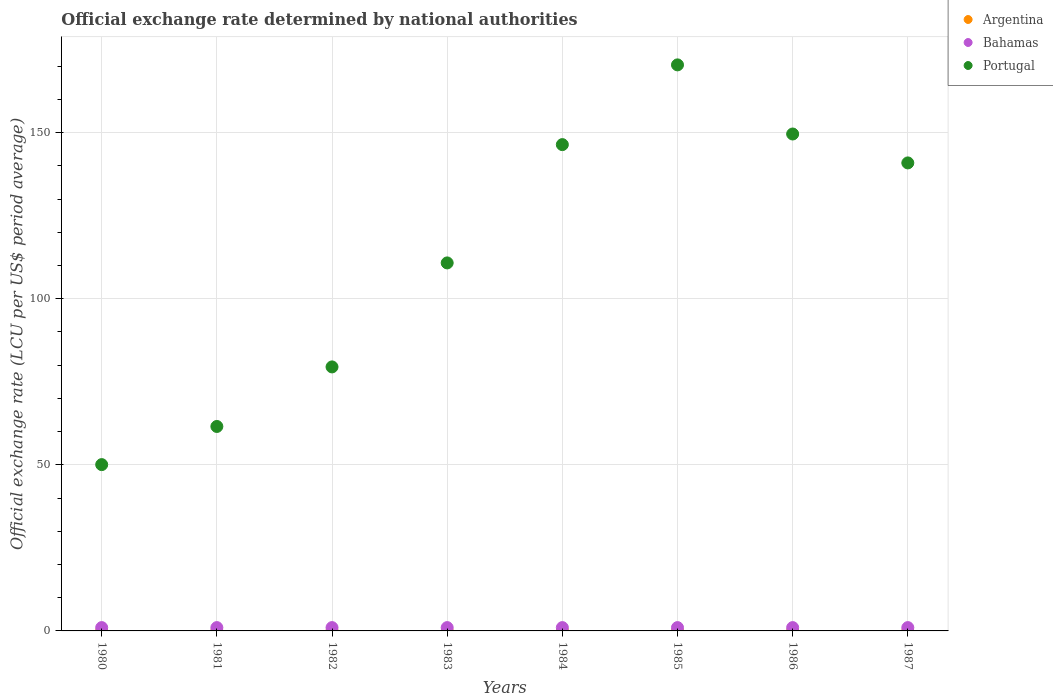How many different coloured dotlines are there?
Give a very brief answer. 3. What is the official exchange rate in Argentina in 1987?
Offer a terse response. 0. Across all years, what is the minimum official exchange rate in Portugal?
Keep it short and to the point. 50.06. In which year was the official exchange rate in Argentina minimum?
Provide a short and direct response. 1980. What is the total official exchange rate in Argentina in the graph?
Ensure brevity in your answer.  0. What is the difference between the official exchange rate in Argentina in 1982 and that in 1987?
Give a very brief answer. -0. What is the difference between the official exchange rate in Bahamas in 1983 and the official exchange rate in Argentina in 1982?
Provide a succinct answer. 1. What is the average official exchange rate in Bahamas per year?
Offer a terse response. 1. In the year 1986, what is the difference between the official exchange rate in Bahamas and official exchange rate in Portugal?
Give a very brief answer. -148.59. What is the ratio of the official exchange rate in Argentina in 1984 to that in 1985?
Provide a succinct answer. 0.11. Is the official exchange rate in Argentina in 1981 less than that in 1986?
Give a very brief answer. Yes. What is the difference between the highest and the second highest official exchange rate in Argentina?
Your answer should be very brief. 0. What is the difference between the highest and the lowest official exchange rate in Bahamas?
Your answer should be very brief. 9.999999717180685e-10. In how many years, is the official exchange rate in Portugal greater than the average official exchange rate in Portugal taken over all years?
Offer a terse response. 4. Is it the case that in every year, the sum of the official exchange rate in Portugal and official exchange rate in Argentina  is greater than the official exchange rate in Bahamas?
Give a very brief answer. Yes. Is the official exchange rate in Portugal strictly less than the official exchange rate in Argentina over the years?
Your answer should be very brief. No. How many years are there in the graph?
Keep it short and to the point. 8. Are the values on the major ticks of Y-axis written in scientific E-notation?
Provide a short and direct response. No. What is the title of the graph?
Give a very brief answer. Official exchange rate determined by national authorities. What is the label or title of the Y-axis?
Give a very brief answer. Official exchange rate (LCU per US$ period average). What is the Official exchange rate (LCU per US$ period average) in Argentina in 1980?
Keep it short and to the point. 1.83715833333225e-8. What is the Official exchange rate (LCU per US$ period average) in Bahamas in 1980?
Your answer should be very brief. 1. What is the Official exchange rate (LCU per US$ period average) of Portugal in 1980?
Offer a very short reply. 50.06. What is the Official exchange rate (LCU per US$ period average) of Argentina in 1981?
Your response must be concise. 4.40269166666725e-8. What is the Official exchange rate (LCU per US$ period average) in Bahamas in 1981?
Offer a very short reply. 1. What is the Official exchange rate (LCU per US$ period average) of Portugal in 1981?
Ensure brevity in your answer.  61.55. What is the Official exchange rate (LCU per US$ period average) of Argentina in 1982?
Make the answer very short. 2.592253333332631e-7. What is the Official exchange rate (LCU per US$ period average) of Bahamas in 1982?
Keep it short and to the point. 1. What is the Official exchange rate (LCU per US$ period average) in Portugal in 1982?
Your response must be concise. 79.47. What is the Official exchange rate (LCU per US$ period average) in Argentina in 1983?
Your answer should be compact. 1.05299574995841e-6. What is the Official exchange rate (LCU per US$ period average) of Bahamas in 1983?
Provide a short and direct response. 1. What is the Official exchange rate (LCU per US$ period average) of Portugal in 1983?
Keep it short and to the point. 110.78. What is the Official exchange rate (LCU per US$ period average) in Argentina in 1984?
Ensure brevity in your answer.  6.7649116666e-6. What is the Official exchange rate (LCU per US$ period average) in Bahamas in 1984?
Your answer should be compact. 1. What is the Official exchange rate (LCU per US$ period average) of Portugal in 1984?
Your response must be concise. 146.39. What is the Official exchange rate (LCU per US$ period average) in Argentina in 1985?
Your answer should be very brief. 6.01809e-5. What is the Official exchange rate (LCU per US$ period average) in Bahamas in 1985?
Your response must be concise. 1. What is the Official exchange rate (LCU per US$ period average) in Portugal in 1985?
Offer a terse response. 170.39. What is the Official exchange rate (LCU per US$ period average) of Argentina in 1986?
Your response must be concise. 9.43031666666667e-5. What is the Official exchange rate (LCU per US$ period average) of Portugal in 1986?
Ensure brevity in your answer.  149.59. What is the Official exchange rate (LCU per US$ period average) in Argentina in 1987?
Give a very brief answer. 0. What is the Official exchange rate (LCU per US$ period average) in Portugal in 1987?
Your answer should be very brief. 140.88. Across all years, what is the maximum Official exchange rate (LCU per US$ period average) of Argentina?
Make the answer very short. 0. Across all years, what is the maximum Official exchange rate (LCU per US$ period average) of Portugal?
Your answer should be compact. 170.39. Across all years, what is the minimum Official exchange rate (LCU per US$ period average) in Argentina?
Make the answer very short. 1.83715833333225e-8. Across all years, what is the minimum Official exchange rate (LCU per US$ period average) of Bahamas?
Keep it short and to the point. 1. Across all years, what is the minimum Official exchange rate (LCU per US$ period average) in Portugal?
Keep it short and to the point. 50.06. What is the total Official exchange rate (LCU per US$ period average) in Argentina in the graph?
Offer a very short reply. 0. What is the total Official exchange rate (LCU per US$ period average) in Portugal in the graph?
Provide a succinct answer. 909.12. What is the difference between the Official exchange rate (LCU per US$ period average) of Bahamas in 1980 and that in 1981?
Provide a short and direct response. 0. What is the difference between the Official exchange rate (LCU per US$ period average) in Portugal in 1980 and that in 1981?
Give a very brief answer. -11.48. What is the difference between the Official exchange rate (LCU per US$ period average) of Argentina in 1980 and that in 1982?
Give a very brief answer. -0. What is the difference between the Official exchange rate (LCU per US$ period average) in Portugal in 1980 and that in 1982?
Your answer should be very brief. -29.41. What is the difference between the Official exchange rate (LCU per US$ period average) of Argentina in 1980 and that in 1983?
Give a very brief answer. -0. What is the difference between the Official exchange rate (LCU per US$ period average) in Portugal in 1980 and that in 1983?
Your answer should be compact. -60.72. What is the difference between the Official exchange rate (LCU per US$ period average) in Bahamas in 1980 and that in 1984?
Provide a short and direct response. -0. What is the difference between the Official exchange rate (LCU per US$ period average) in Portugal in 1980 and that in 1984?
Provide a short and direct response. -96.33. What is the difference between the Official exchange rate (LCU per US$ period average) of Argentina in 1980 and that in 1985?
Provide a succinct answer. -0. What is the difference between the Official exchange rate (LCU per US$ period average) of Bahamas in 1980 and that in 1985?
Your answer should be compact. -0. What is the difference between the Official exchange rate (LCU per US$ period average) in Portugal in 1980 and that in 1985?
Offer a terse response. -120.33. What is the difference between the Official exchange rate (LCU per US$ period average) in Argentina in 1980 and that in 1986?
Your answer should be compact. -0. What is the difference between the Official exchange rate (LCU per US$ period average) of Bahamas in 1980 and that in 1986?
Ensure brevity in your answer.  -0. What is the difference between the Official exchange rate (LCU per US$ period average) in Portugal in 1980 and that in 1986?
Provide a succinct answer. -99.52. What is the difference between the Official exchange rate (LCU per US$ period average) of Argentina in 1980 and that in 1987?
Give a very brief answer. -0. What is the difference between the Official exchange rate (LCU per US$ period average) in Portugal in 1980 and that in 1987?
Make the answer very short. -90.82. What is the difference between the Official exchange rate (LCU per US$ period average) in Bahamas in 1981 and that in 1982?
Keep it short and to the point. 0. What is the difference between the Official exchange rate (LCU per US$ period average) in Portugal in 1981 and that in 1982?
Your answer should be compact. -17.93. What is the difference between the Official exchange rate (LCU per US$ period average) of Portugal in 1981 and that in 1983?
Make the answer very short. -49.23. What is the difference between the Official exchange rate (LCU per US$ period average) in Argentina in 1981 and that in 1984?
Offer a very short reply. -0. What is the difference between the Official exchange rate (LCU per US$ period average) of Portugal in 1981 and that in 1984?
Make the answer very short. -84.84. What is the difference between the Official exchange rate (LCU per US$ period average) of Argentina in 1981 and that in 1985?
Give a very brief answer. -0. What is the difference between the Official exchange rate (LCU per US$ period average) of Bahamas in 1981 and that in 1985?
Your response must be concise. -0. What is the difference between the Official exchange rate (LCU per US$ period average) in Portugal in 1981 and that in 1985?
Your answer should be compact. -108.85. What is the difference between the Official exchange rate (LCU per US$ period average) of Argentina in 1981 and that in 1986?
Provide a succinct answer. -0. What is the difference between the Official exchange rate (LCU per US$ period average) of Portugal in 1981 and that in 1986?
Provide a succinct answer. -88.04. What is the difference between the Official exchange rate (LCU per US$ period average) of Argentina in 1981 and that in 1987?
Your answer should be very brief. -0. What is the difference between the Official exchange rate (LCU per US$ period average) of Bahamas in 1981 and that in 1987?
Keep it short and to the point. -0. What is the difference between the Official exchange rate (LCU per US$ period average) in Portugal in 1981 and that in 1987?
Ensure brevity in your answer.  -79.34. What is the difference between the Official exchange rate (LCU per US$ period average) of Bahamas in 1982 and that in 1983?
Give a very brief answer. 0. What is the difference between the Official exchange rate (LCU per US$ period average) in Portugal in 1982 and that in 1983?
Your response must be concise. -31.31. What is the difference between the Official exchange rate (LCU per US$ period average) in Argentina in 1982 and that in 1984?
Make the answer very short. -0. What is the difference between the Official exchange rate (LCU per US$ period average) of Bahamas in 1982 and that in 1984?
Your answer should be very brief. -0. What is the difference between the Official exchange rate (LCU per US$ period average) of Portugal in 1982 and that in 1984?
Give a very brief answer. -66.92. What is the difference between the Official exchange rate (LCU per US$ period average) of Argentina in 1982 and that in 1985?
Your response must be concise. -0. What is the difference between the Official exchange rate (LCU per US$ period average) of Portugal in 1982 and that in 1985?
Ensure brevity in your answer.  -90.92. What is the difference between the Official exchange rate (LCU per US$ period average) in Argentina in 1982 and that in 1986?
Offer a very short reply. -0. What is the difference between the Official exchange rate (LCU per US$ period average) of Bahamas in 1982 and that in 1986?
Keep it short and to the point. -0. What is the difference between the Official exchange rate (LCU per US$ period average) of Portugal in 1982 and that in 1986?
Provide a short and direct response. -70.11. What is the difference between the Official exchange rate (LCU per US$ period average) of Argentina in 1982 and that in 1987?
Offer a terse response. -0. What is the difference between the Official exchange rate (LCU per US$ period average) of Bahamas in 1982 and that in 1987?
Your response must be concise. -0. What is the difference between the Official exchange rate (LCU per US$ period average) of Portugal in 1982 and that in 1987?
Give a very brief answer. -61.41. What is the difference between the Official exchange rate (LCU per US$ period average) of Argentina in 1983 and that in 1984?
Offer a terse response. -0. What is the difference between the Official exchange rate (LCU per US$ period average) in Portugal in 1983 and that in 1984?
Your response must be concise. -35.61. What is the difference between the Official exchange rate (LCU per US$ period average) in Argentina in 1983 and that in 1985?
Your response must be concise. -0. What is the difference between the Official exchange rate (LCU per US$ period average) of Portugal in 1983 and that in 1985?
Provide a succinct answer. -59.61. What is the difference between the Official exchange rate (LCU per US$ period average) in Argentina in 1983 and that in 1986?
Ensure brevity in your answer.  -0. What is the difference between the Official exchange rate (LCU per US$ period average) in Bahamas in 1983 and that in 1986?
Your answer should be very brief. -0. What is the difference between the Official exchange rate (LCU per US$ period average) in Portugal in 1983 and that in 1986?
Your answer should be very brief. -38.81. What is the difference between the Official exchange rate (LCU per US$ period average) of Argentina in 1983 and that in 1987?
Your answer should be very brief. -0. What is the difference between the Official exchange rate (LCU per US$ period average) in Portugal in 1983 and that in 1987?
Your response must be concise. -30.1. What is the difference between the Official exchange rate (LCU per US$ period average) of Argentina in 1984 and that in 1985?
Ensure brevity in your answer.  -0. What is the difference between the Official exchange rate (LCU per US$ period average) in Bahamas in 1984 and that in 1985?
Your answer should be very brief. -0. What is the difference between the Official exchange rate (LCU per US$ period average) in Portugal in 1984 and that in 1985?
Keep it short and to the point. -24. What is the difference between the Official exchange rate (LCU per US$ period average) in Argentina in 1984 and that in 1986?
Offer a very short reply. -0. What is the difference between the Official exchange rate (LCU per US$ period average) in Portugal in 1984 and that in 1986?
Offer a terse response. -3.2. What is the difference between the Official exchange rate (LCU per US$ period average) in Argentina in 1984 and that in 1987?
Keep it short and to the point. -0. What is the difference between the Official exchange rate (LCU per US$ period average) of Portugal in 1984 and that in 1987?
Provide a succinct answer. 5.51. What is the difference between the Official exchange rate (LCU per US$ period average) of Bahamas in 1985 and that in 1986?
Keep it short and to the point. 0. What is the difference between the Official exchange rate (LCU per US$ period average) of Portugal in 1985 and that in 1986?
Ensure brevity in your answer.  20.81. What is the difference between the Official exchange rate (LCU per US$ period average) in Argentina in 1985 and that in 1987?
Your answer should be compact. -0. What is the difference between the Official exchange rate (LCU per US$ period average) in Bahamas in 1985 and that in 1987?
Your answer should be very brief. 0. What is the difference between the Official exchange rate (LCU per US$ period average) in Portugal in 1985 and that in 1987?
Keep it short and to the point. 29.51. What is the difference between the Official exchange rate (LCU per US$ period average) of Argentina in 1986 and that in 1987?
Provide a succinct answer. -0. What is the difference between the Official exchange rate (LCU per US$ period average) in Portugal in 1986 and that in 1987?
Give a very brief answer. 8.7. What is the difference between the Official exchange rate (LCU per US$ period average) of Argentina in 1980 and the Official exchange rate (LCU per US$ period average) of Bahamas in 1981?
Your answer should be very brief. -1. What is the difference between the Official exchange rate (LCU per US$ period average) in Argentina in 1980 and the Official exchange rate (LCU per US$ period average) in Portugal in 1981?
Ensure brevity in your answer.  -61.55. What is the difference between the Official exchange rate (LCU per US$ period average) in Bahamas in 1980 and the Official exchange rate (LCU per US$ period average) in Portugal in 1981?
Provide a short and direct response. -60.55. What is the difference between the Official exchange rate (LCU per US$ period average) of Argentina in 1980 and the Official exchange rate (LCU per US$ period average) of Portugal in 1982?
Your response must be concise. -79.47. What is the difference between the Official exchange rate (LCU per US$ period average) of Bahamas in 1980 and the Official exchange rate (LCU per US$ period average) of Portugal in 1982?
Provide a short and direct response. -78.47. What is the difference between the Official exchange rate (LCU per US$ period average) of Argentina in 1980 and the Official exchange rate (LCU per US$ period average) of Portugal in 1983?
Keep it short and to the point. -110.78. What is the difference between the Official exchange rate (LCU per US$ period average) of Bahamas in 1980 and the Official exchange rate (LCU per US$ period average) of Portugal in 1983?
Offer a very short reply. -109.78. What is the difference between the Official exchange rate (LCU per US$ period average) of Argentina in 1980 and the Official exchange rate (LCU per US$ period average) of Portugal in 1984?
Offer a very short reply. -146.39. What is the difference between the Official exchange rate (LCU per US$ period average) of Bahamas in 1980 and the Official exchange rate (LCU per US$ period average) of Portugal in 1984?
Keep it short and to the point. -145.39. What is the difference between the Official exchange rate (LCU per US$ period average) of Argentina in 1980 and the Official exchange rate (LCU per US$ period average) of Portugal in 1985?
Provide a short and direct response. -170.39. What is the difference between the Official exchange rate (LCU per US$ period average) of Bahamas in 1980 and the Official exchange rate (LCU per US$ period average) of Portugal in 1985?
Provide a short and direct response. -169.39. What is the difference between the Official exchange rate (LCU per US$ period average) of Argentina in 1980 and the Official exchange rate (LCU per US$ period average) of Portugal in 1986?
Offer a terse response. -149.59. What is the difference between the Official exchange rate (LCU per US$ period average) in Bahamas in 1980 and the Official exchange rate (LCU per US$ period average) in Portugal in 1986?
Ensure brevity in your answer.  -148.59. What is the difference between the Official exchange rate (LCU per US$ period average) of Argentina in 1980 and the Official exchange rate (LCU per US$ period average) of Portugal in 1987?
Give a very brief answer. -140.88. What is the difference between the Official exchange rate (LCU per US$ period average) in Bahamas in 1980 and the Official exchange rate (LCU per US$ period average) in Portugal in 1987?
Provide a succinct answer. -139.88. What is the difference between the Official exchange rate (LCU per US$ period average) in Argentina in 1981 and the Official exchange rate (LCU per US$ period average) in Bahamas in 1982?
Provide a succinct answer. -1. What is the difference between the Official exchange rate (LCU per US$ period average) in Argentina in 1981 and the Official exchange rate (LCU per US$ period average) in Portugal in 1982?
Provide a succinct answer. -79.47. What is the difference between the Official exchange rate (LCU per US$ period average) of Bahamas in 1981 and the Official exchange rate (LCU per US$ period average) of Portugal in 1982?
Your answer should be very brief. -78.47. What is the difference between the Official exchange rate (LCU per US$ period average) of Argentina in 1981 and the Official exchange rate (LCU per US$ period average) of Portugal in 1983?
Your answer should be compact. -110.78. What is the difference between the Official exchange rate (LCU per US$ period average) in Bahamas in 1981 and the Official exchange rate (LCU per US$ period average) in Portugal in 1983?
Your answer should be compact. -109.78. What is the difference between the Official exchange rate (LCU per US$ period average) in Argentina in 1981 and the Official exchange rate (LCU per US$ period average) in Bahamas in 1984?
Ensure brevity in your answer.  -1. What is the difference between the Official exchange rate (LCU per US$ period average) of Argentina in 1981 and the Official exchange rate (LCU per US$ period average) of Portugal in 1984?
Provide a succinct answer. -146.39. What is the difference between the Official exchange rate (LCU per US$ period average) in Bahamas in 1981 and the Official exchange rate (LCU per US$ period average) in Portugal in 1984?
Your answer should be compact. -145.39. What is the difference between the Official exchange rate (LCU per US$ period average) of Argentina in 1981 and the Official exchange rate (LCU per US$ period average) of Bahamas in 1985?
Make the answer very short. -1. What is the difference between the Official exchange rate (LCU per US$ period average) of Argentina in 1981 and the Official exchange rate (LCU per US$ period average) of Portugal in 1985?
Keep it short and to the point. -170.39. What is the difference between the Official exchange rate (LCU per US$ period average) of Bahamas in 1981 and the Official exchange rate (LCU per US$ period average) of Portugal in 1985?
Your response must be concise. -169.39. What is the difference between the Official exchange rate (LCU per US$ period average) of Argentina in 1981 and the Official exchange rate (LCU per US$ period average) of Portugal in 1986?
Provide a short and direct response. -149.59. What is the difference between the Official exchange rate (LCU per US$ period average) of Bahamas in 1981 and the Official exchange rate (LCU per US$ period average) of Portugal in 1986?
Ensure brevity in your answer.  -148.59. What is the difference between the Official exchange rate (LCU per US$ period average) in Argentina in 1981 and the Official exchange rate (LCU per US$ period average) in Bahamas in 1987?
Your response must be concise. -1. What is the difference between the Official exchange rate (LCU per US$ period average) in Argentina in 1981 and the Official exchange rate (LCU per US$ period average) in Portugal in 1987?
Your answer should be very brief. -140.88. What is the difference between the Official exchange rate (LCU per US$ period average) of Bahamas in 1981 and the Official exchange rate (LCU per US$ period average) of Portugal in 1987?
Offer a terse response. -139.88. What is the difference between the Official exchange rate (LCU per US$ period average) of Argentina in 1982 and the Official exchange rate (LCU per US$ period average) of Portugal in 1983?
Your answer should be very brief. -110.78. What is the difference between the Official exchange rate (LCU per US$ period average) of Bahamas in 1982 and the Official exchange rate (LCU per US$ period average) of Portugal in 1983?
Your answer should be very brief. -109.78. What is the difference between the Official exchange rate (LCU per US$ period average) of Argentina in 1982 and the Official exchange rate (LCU per US$ period average) of Bahamas in 1984?
Make the answer very short. -1. What is the difference between the Official exchange rate (LCU per US$ period average) in Argentina in 1982 and the Official exchange rate (LCU per US$ period average) in Portugal in 1984?
Keep it short and to the point. -146.39. What is the difference between the Official exchange rate (LCU per US$ period average) of Bahamas in 1982 and the Official exchange rate (LCU per US$ period average) of Portugal in 1984?
Make the answer very short. -145.39. What is the difference between the Official exchange rate (LCU per US$ period average) of Argentina in 1982 and the Official exchange rate (LCU per US$ period average) of Portugal in 1985?
Provide a short and direct response. -170.39. What is the difference between the Official exchange rate (LCU per US$ period average) of Bahamas in 1982 and the Official exchange rate (LCU per US$ period average) of Portugal in 1985?
Your response must be concise. -169.39. What is the difference between the Official exchange rate (LCU per US$ period average) of Argentina in 1982 and the Official exchange rate (LCU per US$ period average) of Bahamas in 1986?
Your answer should be compact. -1. What is the difference between the Official exchange rate (LCU per US$ period average) in Argentina in 1982 and the Official exchange rate (LCU per US$ period average) in Portugal in 1986?
Give a very brief answer. -149.59. What is the difference between the Official exchange rate (LCU per US$ period average) of Bahamas in 1982 and the Official exchange rate (LCU per US$ period average) of Portugal in 1986?
Ensure brevity in your answer.  -148.59. What is the difference between the Official exchange rate (LCU per US$ period average) of Argentina in 1982 and the Official exchange rate (LCU per US$ period average) of Bahamas in 1987?
Keep it short and to the point. -1. What is the difference between the Official exchange rate (LCU per US$ period average) in Argentina in 1982 and the Official exchange rate (LCU per US$ period average) in Portugal in 1987?
Offer a very short reply. -140.88. What is the difference between the Official exchange rate (LCU per US$ period average) in Bahamas in 1982 and the Official exchange rate (LCU per US$ period average) in Portugal in 1987?
Provide a succinct answer. -139.88. What is the difference between the Official exchange rate (LCU per US$ period average) in Argentina in 1983 and the Official exchange rate (LCU per US$ period average) in Bahamas in 1984?
Your response must be concise. -1. What is the difference between the Official exchange rate (LCU per US$ period average) of Argentina in 1983 and the Official exchange rate (LCU per US$ period average) of Portugal in 1984?
Offer a very short reply. -146.39. What is the difference between the Official exchange rate (LCU per US$ period average) of Bahamas in 1983 and the Official exchange rate (LCU per US$ period average) of Portugal in 1984?
Ensure brevity in your answer.  -145.39. What is the difference between the Official exchange rate (LCU per US$ period average) of Argentina in 1983 and the Official exchange rate (LCU per US$ period average) of Portugal in 1985?
Offer a very short reply. -170.39. What is the difference between the Official exchange rate (LCU per US$ period average) in Bahamas in 1983 and the Official exchange rate (LCU per US$ period average) in Portugal in 1985?
Your response must be concise. -169.39. What is the difference between the Official exchange rate (LCU per US$ period average) in Argentina in 1983 and the Official exchange rate (LCU per US$ period average) in Portugal in 1986?
Your response must be concise. -149.59. What is the difference between the Official exchange rate (LCU per US$ period average) of Bahamas in 1983 and the Official exchange rate (LCU per US$ period average) of Portugal in 1986?
Provide a succinct answer. -148.59. What is the difference between the Official exchange rate (LCU per US$ period average) of Argentina in 1983 and the Official exchange rate (LCU per US$ period average) of Bahamas in 1987?
Offer a terse response. -1. What is the difference between the Official exchange rate (LCU per US$ period average) in Argentina in 1983 and the Official exchange rate (LCU per US$ period average) in Portugal in 1987?
Your response must be concise. -140.88. What is the difference between the Official exchange rate (LCU per US$ period average) of Bahamas in 1983 and the Official exchange rate (LCU per US$ period average) of Portugal in 1987?
Offer a terse response. -139.88. What is the difference between the Official exchange rate (LCU per US$ period average) of Argentina in 1984 and the Official exchange rate (LCU per US$ period average) of Portugal in 1985?
Give a very brief answer. -170.39. What is the difference between the Official exchange rate (LCU per US$ period average) of Bahamas in 1984 and the Official exchange rate (LCU per US$ period average) of Portugal in 1985?
Ensure brevity in your answer.  -169.39. What is the difference between the Official exchange rate (LCU per US$ period average) of Argentina in 1984 and the Official exchange rate (LCU per US$ period average) of Portugal in 1986?
Give a very brief answer. -149.59. What is the difference between the Official exchange rate (LCU per US$ period average) in Bahamas in 1984 and the Official exchange rate (LCU per US$ period average) in Portugal in 1986?
Provide a succinct answer. -148.59. What is the difference between the Official exchange rate (LCU per US$ period average) in Argentina in 1984 and the Official exchange rate (LCU per US$ period average) in Portugal in 1987?
Give a very brief answer. -140.88. What is the difference between the Official exchange rate (LCU per US$ period average) in Bahamas in 1984 and the Official exchange rate (LCU per US$ period average) in Portugal in 1987?
Offer a terse response. -139.88. What is the difference between the Official exchange rate (LCU per US$ period average) in Argentina in 1985 and the Official exchange rate (LCU per US$ period average) in Bahamas in 1986?
Keep it short and to the point. -1. What is the difference between the Official exchange rate (LCU per US$ period average) of Argentina in 1985 and the Official exchange rate (LCU per US$ period average) of Portugal in 1986?
Provide a short and direct response. -149.59. What is the difference between the Official exchange rate (LCU per US$ period average) in Bahamas in 1985 and the Official exchange rate (LCU per US$ period average) in Portugal in 1986?
Give a very brief answer. -148.59. What is the difference between the Official exchange rate (LCU per US$ period average) of Argentina in 1985 and the Official exchange rate (LCU per US$ period average) of Bahamas in 1987?
Your response must be concise. -1. What is the difference between the Official exchange rate (LCU per US$ period average) of Argentina in 1985 and the Official exchange rate (LCU per US$ period average) of Portugal in 1987?
Your answer should be very brief. -140.88. What is the difference between the Official exchange rate (LCU per US$ period average) of Bahamas in 1985 and the Official exchange rate (LCU per US$ period average) of Portugal in 1987?
Provide a short and direct response. -139.88. What is the difference between the Official exchange rate (LCU per US$ period average) of Argentina in 1986 and the Official exchange rate (LCU per US$ period average) of Bahamas in 1987?
Your answer should be compact. -1. What is the difference between the Official exchange rate (LCU per US$ period average) in Argentina in 1986 and the Official exchange rate (LCU per US$ period average) in Portugal in 1987?
Your answer should be compact. -140.88. What is the difference between the Official exchange rate (LCU per US$ period average) in Bahamas in 1986 and the Official exchange rate (LCU per US$ period average) in Portugal in 1987?
Keep it short and to the point. -139.88. What is the average Official exchange rate (LCU per US$ period average) of Argentina per year?
Make the answer very short. 0. What is the average Official exchange rate (LCU per US$ period average) in Bahamas per year?
Give a very brief answer. 1. What is the average Official exchange rate (LCU per US$ period average) in Portugal per year?
Ensure brevity in your answer.  113.64. In the year 1980, what is the difference between the Official exchange rate (LCU per US$ period average) in Argentina and Official exchange rate (LCU per US$ period average) in Bahamas?
Provide a succinct answer. -1. In the year 1980, what is the difference between the Official exchange rate (LCU per US$ period average) in Argentina and Official exchange rate (LCU per US$ period average) in Portugal?
Your answer should be very brief. -50.06. In the year 1980, what is the difference between the Official exchange rate (LCU per US$ period average) in Bahamas and Official exchange rate (LCU per US$ period average) in Portugal?
Keep it short and to the point. -49.06. In the year 1981, what is the difference between the Official exchange rate (LCU per US$ period average) in Argentina and Official exchange rate (LCU per US$ period average) in Portugal?
Your response must be concise. -61.55. In the year 1981, what is the difference between the Official exchange rate (LCU per US$ period average) in Bahamas and Official exchange rate (LCU per US$ period average) in Portugal?
Provide a short and direct response. -60.55. In the year 1982, what is the difference between the Official exchange rate (LCU per US$ period average) of Argentina and Official exchange rate (LCU per US$ period average) of Portugal?
Your response must be concise. -79.47. In the year 1982, what is the difference between the Official exchange rate (LCU per US$ period average) in Bahamas and Official exchange rate (LCU per US$ period average) in Portugal?
Make the answer very short. -78.47. In the year 1983, what is the difference between the Official exchange rate (LCU per US$ period average) of Argentina and Official exchange rate (LCU per US$ period average) of Bahamas?
Offer a very short reply. -1. In the year 1983, what is the difference between the Official exchange rate (LCU per US$ period average) in Argentina and Official exchange rate (LCU per US$ period average) in Portugal?
Ensure brevity in your answer.  -110.78. In the year 1983, what is the difference between the Official exchange rate (LCU per US$ period average) of Bahamas and Official exchange rate (LCU per US$ period average) of Portugal?
Your answer should be very brief. -109.78. In the year 1984, what is the difference between the Official exchange rate (LCU per US$ period average) in Argentina and Official exchange rate (LCU per US$ period average) in Bahamas?
Your answer should be very brief. -1. In the year 1984, what is the difference between the Official exchange rate (LCU per US$ period average) in Argentina and Official exchange rate (LCU per US$ period average) in Portugal?
Make the answer very short. -146.39. In the year 1984, what is the difference between the Official exchange rate (LCU per US$ period average) of Bahamas and Official exchange rate (LCU per US$ period average) of Portugal?
Ensure brevity in your answer.  -145.39. In the year 1985, what is the difference between the Official exchange rate (LCU per US$ period average) of Argentina and Official exchange rate (LCU per US$ period average) of Bahamas?
Provide a short and direct response. -1. In the year 1985, what is the difference between the Official exchange rate (LCU per US$ period average) of Argentina and Official exchange rate (LCU per US$ period average) of Portugal?
Ensure brevity in your answer.  -170.39. In the year 1985, what is the difference between the Official exchange rate (LCU per US$ period average) of Bahamas and Official exchange rate (LCU per US$ period average) of Portugal?
Keep it short and to the point. -169.39. In the year 1986, what is the difference between the Official exchange rate (LCU per US$ period average) in Argentina and Official exchange rate (LCU per US$ period average) in Bahamas?
Ensure brevity in your answer.  -1. In the year 1986, what is the difference between the Official exchange rate (LCU per US$ period average) in Argentina and Official exchange rate (LCU per US$ period average) in Portugal?
Give a very brief answer. -149.59. In the year 1986, what is the difference between the Official exchange rate (LCU per US$ period average) of Bahamas and Official exchange rate (LCU per US$ period average) of Portugal?
Offer a terse response. -148.59. In the year 1987, what is the difference between the Official exchange rate (LCU per US$ period average) in Argentina and Official exchange rate (LCU per US$ period average) in Bahamas?
Provide a succinct answer. -1. In the year 1987, what is the difference between the Official exchange rate (LCU per US$ period average) in Argentina and Official exchange rate (LCU per US$ period average) in Portugal?
Make the answer very short. -140.88. In the year 1987, what is the difference between the Official exchange rate (LCU per US$ period average) in Bahamas and Official exchange rate (LCU per US$ period average) in Portugal?
Offer a terse response. -139.88. What is the ratio of the Official exchange rate (LCU per US$ period average) of Argentina in 1980 to that in 1981?
Your answer should be compact. 0.42. What is the ratio of the Official exchange rate (LCU per US$ period average) in Bahamas in 1980 to that in 1981?
Your answer should be very brief. 1. What is the ratio of the Official exchange rate (LCU per US$ period average) of Portugal in 1980 to that in 1981?
Provide a short and direct response. 0.81. What is the ratio of the Official exchange rate (LCU per US$ period average) of Argentina in 1980 to that in 1982?
Make the answer very short. 0.07. What is the ratio of the Official exchange rate (LCU per US$ period average) of Bahamas in 1980 to that in 1982?
Your answer should be very brief. 1. What is the ratio of the Official exchange rate (LCU per US$ period average) in Portugal in 1980 to that in 1982?
Your answer should be very brief. 0.63. What is the ratio of the Official exchange rate (LCU per US$ period average) of Argentina in 1980 to that in 1983?
Provide a succinct answer. 0.02. What is the ratio of the Official exchange rate (LCU per US$ period average) in Bahamas in 1980 to that in 1983?
Give a very brief answer. 1. What is the ratio of the Official exchange rate (LCU per US$ period average) of Portugal in 1980 to that in 1983?
Offer a terse response. 0.45. What is the ratio of the Official exchange rate (LCU per US$ period average) in Argentina in 1980 to that in 1984?
Ensure brevity in your answer.  0. What is the ratio of the Official exchange rate (LCU per US$ period average) in Bahamas in 1980 to that in 1984?
Ensure brevity in your answer.  1. What is the ratio of the Official exchange rate (LCU per US$ period average) in Portugal in 1980 to that in 1984?
Your response must be concise. 0.34. What is the ratio of the Official exchange rate (LCU per US$ period average) of Bahamas in 1980 to that in 1985?
Your answer should be very brief. 1. What is the ratio of the Official exchange rate (LCU per US$ period average) of Portugal in 1980 to that in 1985?
Offer a very short reply. 0.29. What is the ratio of the Official exchange rate (LCU per US$ period average) of Bahamas in 1980 to that in 1986?
Provide a short and direct response. 1. What is the ratio of the Official exchange rate (LCU per US$ period average) in Portugal in 1980 to that in 1986?
Your answer should be very brief. 0.33. What is the ratio of the Official exchange rate (LCU per US$ period average) of Argentina in 1980 to that in 1987?
Ensure brevity in your answer.  0. What is the ratio of the Official exchange rate (LCU per US$ period average) in Portugal in 1980 to that in 1987?
Provide a succinct answer. 0.36. What is the ratio of the Official exchange rate (LCU per US$ period average) of Argentina in 1981 to that in 1982?
Ensure brevity in your answer.  0.17. What is the ratio of the Official exchange rate (LCU per US$ period average) of Portugal in 1981 to that in 1982?
Provide a short and direct response. 0.77. What is the ratio of the Official exchange rate (LCU per US$ period average) of Argentina in 1981 to that in 1983?
Your answer should be compact. 0.04. What is the ratio of the Official exchange rate (LCU per US$ period average) in Portugal in 1981 to that in 1983?
Offer a terse response. 0.56. What is the ratio of the Official exchange rate (LCU per US$ period average) in Argentina in 1981 to that in 1984?
Your response must be concise. 0.01. What is the ratio of the Official exchange rate (LCU per US$ period average) in Bahamas in 1981 to that in 1984?
Provide a succinct answer. 1. What is the ratio of the Official exchange rate (LCU per US$ period average) in Portugal in 1981 to that in 1984?
Ensure brevity in your answer.  0.42. What is the ratio of the Official exchange rate (LCU per US$ period average) of Argentina in 1981 to that in 1985?
Make the answer very short. 0. What is the ratio of the Official exchange rate (LCU per US$ period average) in Portugal in 1981 to that in 1985?
Give a very brief answer. 0.36. What is the ratio of the Official exchange rate (LCU per US$ period average) in Bahamas in 1981 to that in 1986?
Your answer should be compact. 1. What is the ratio of the Official exchange rate (LCU per US$ period average) in Portugal in 1981 to that in 1986?
Make the answer very short. 0.41. What is the ratio of the Official exchange rate (LCU per US$ period average) in Bahamas in 1981 to that in 1987?
Provide a short and direct response. 1. What is the ratio of the Official exchange rate (LCU per US$ period average) of Portugal in 1981 to that in 1987?
Make the answer very short. 0.44. What is the ratio of the Official exchange rate (LCU per US$ period average) of Argentina in 1982 to that in 1983?
Offer a terse response. 0.25. What is the ratio of the Official exchange rate (LCU per US$ period average) of Bahamas in 1982 to that in 1983?
Ensure brevity in your answer.  1. What is the ratio of the Official exchange rate (LCU per US$ period average) in Portugal in 1982 to that in 1983?
Provide a succinct answer. 0.72. What is the ratio of the Official exchange rate (LCU per US$ period average) in Argentina in 1982 to that in 1984?
Make the answer very short. 0.04. What is the ratio of the Official exchange rate (LCU per US$ period average) of Bahamas in 1982 to that in 1984?
Provide a short and direct response. 1. What is the ratio of the Official exchange rate (LCU per US$ period average) in Portugal in 1982 to that in 1984?
Ensure brevity in your answer.  0.54. What is the ratio of the Official exchange rate (LCU per US$ period average) in Argentina in 1982 to that in 1985?
Keep it short and to the point. 0. What is the ratio of the Official exchange rate (LCU per US$ period average) in Bahamas in 1982 to that in 1985?
Offer a very short reply. 1. What is the ratio of the Official exchange rate (LCU per US$ period average) of Portugal in 1982 to that in 1985?
Your answer should be compact. 0.47. What is the ratio of the Official exchange rate (LCU per US$ period average) of Argentina in 1982 to that in 1986?
Keep it short and to the point. 0. What is the ratio of the Official exchange rate (LCU per US$ period average) in Bahamas in 1982 to that in 1986?
Ensure brevity in your answer.  1. What is the ratio of the Official exchange rate (LCU per US$ period average) in Portugal in 1982 to that in 1986?
Provide a succinct answer. 0.53. What is the ratio of the Official exchange rate (LCU per US$ period average) in Argentina in 1982 to that in 1987?
Provide a short and direct response. 0. What is the ratio of the Official exchange rate (LCU per US$ period average) of Bahamas in 1982 to that in 1987?
Your answer should be very brief. 1. What is the ratio of the Official exchange rate (LCU per US$ period average) of Portugal in 1982 to that in 1987?
Ensure brevity in your answer.  0.56. What is the ratio of the Official exchange rate (LCU per US$ period average) in Argentina in 1983 to that in 1984?
Your response must be concise. 0.16. What is the ratio of the Official exchange rate (LCU per US$ period average) in Portugal in 1983 to that in 1984?
Give a very brief answer. 0.76. What is the ratio of the Official exchange rate (LCU per US$ period average) in Argentina in 1983 to that in 1985?
Provide a succinct answer. 0.02. What is the ratio of the Official exchange rate (LCU per US$ period average) of Portugal in 1983 to that in 1985?
Provide a succinct answer. 0.65. What is the ratio of the Official exchange rate (LCU per US$ period average) in Argentina in 1983 to that in 1986?
Keep it short and to the point. 0.01. What is the ratio of the Official exchange rate (LCU per US$ period average) of Bahamas in 1983 to that in 1986?
Ensure brevity in your answer.  1. What is the ratio of the Official exchange rate (LCU per US$ period average) of Portugal in 1983 to that in 1986?
Offer a very short reply. 0.74. What is the ratio of the Official exchange rate (LCU per US$ period average) in Argentina in 1983 to that in 1987?
Ensure brevity in your answer.  0. What is the ratio of the Official exchange rate (LCU per US$ period average) of Bahamas in 1983 to that in 1987?
Give a very brief answer. 1. What is the ratio of the Official exchange rate (LCU per US$ period average) in Portugal in 1983 to that in 1987?
Ensure brevity in your answer.  0.79. What is the ratio of the Official exchange rate (LCU per US$ period average) of Argentina in 1984 to that in 1985?
Your response must be concise. 0.11. What is the ratio of the Official exchange rate (LCU per US$ period average) in Bahamas in 1984 to that in 1985?
Provide a short and direct response. 1. What is the ratio of the Official exchange rate (LCU per US$ period average) of Portugal in 1984 to that in 1985?
Make the answer very short. 0.86. What is the ratio of the Official exchange rate (LCU per US$ period average) of Argentina in 1984 to that in 1986?
Provide a succinct answer. 0.07. What is the ratio of the Official exchange rate (LCU per US$ period average) of Bahamas in 1984 to that in 1986?
Offer a very short reply. 1. What is the ratio of the Official exchange rate (LCU per US$ period average) in Portugal in 1984 to that in 1986?
Your response must be concise. 0.98. What is the ratio of the Official exchange rate (LCU per US$ period average) in Argentina in 1984 to that in 1987?
Keep it short and to the point. 0.03. What is the ratio of the Official exchange rate (LCU per US$ period average) in Portugal in 1984 to that in 1987?
Provide a short and direct response. 1.04. What is the ratio of the Official exchange rate (LCU per US$ period average) in Argentina in 1985 to that in 1986?
Provide a short and direct response. 0.64. What is the ratio of the Official exchange rate (LCU per US$ period average) of Bahamas in 1985 to that in 1986?
Provide a short and direct response. 1. What is the ratio of the Official exchange rate (LCU per US$ period average) in Portugal in 1985 to that in 1986?
Keep it short and to the point. 1.14. What is the ratio of the Official exchange rate (LCU per US$ period average) in Argentina in 1985 to that in 1987?
Offer a very short reply. 0.28. What is the ratio of the Official exchange rate (LCU per US$ period average) in Bahamas in 1985 to that in 1987?
Your response must be concise. 1. What is the ratio of the Official exchange rate (LCU per US$ period average) in Portugal in 1985 to that in 1987?
Keep it short and to the point. 1.21. What is the ratio of the Official exchange rate (LCU per US$ period average) of Argentina in 1986 to that in 1987?
Keep it short and to the point. 0.44. What is the ratio of the Official exchange rate (LCU per US$ period average) of Bahamas in 1986 to that in 1987?
Your answer should be compact. 1. What is the ratio of the Official exchange rate (LCU per US$ period average) in Portugal in 1986 to that in 1987?
Your answer should be compact. 1.06. What is the difference between the highest and the second highest Official exchange rate (LCU per US$ period average) in Argentina?
Give a very brief answer. 0. What is the difference between the highest and the second highest Official exchange rate (LCU per US$ period average) in Bahamas?
Offer a very short reply. 0. What is the difference between the highest and the second highest Official exchange rate (LCU per US$ period average) in Portugal?
Offer a very short reply. 20.81. What is the difference between the highest and the lowest Official exchange rate (LCU per US$ period average) in Argentina?
Make the answer very short. 0. What is the difference between the highest and the lowest Official exchange rate (LCU per US$ period average) of Bahamas?
Make the answer very short. 0. What is the difference between the highest and the lowest Official exchange rate (LCU per US$ period average) in Portugal?
Offer a terse response. 120.33. 